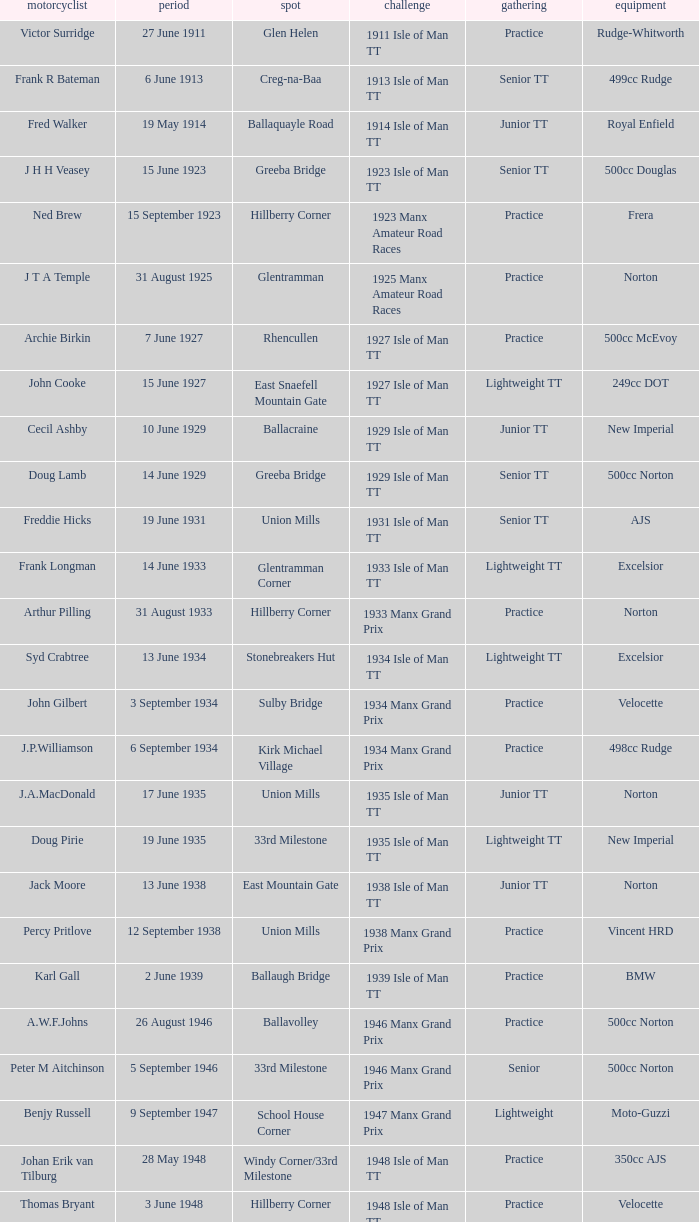What apparatus did kenneth e. herbert operate? 499cc Norton. 